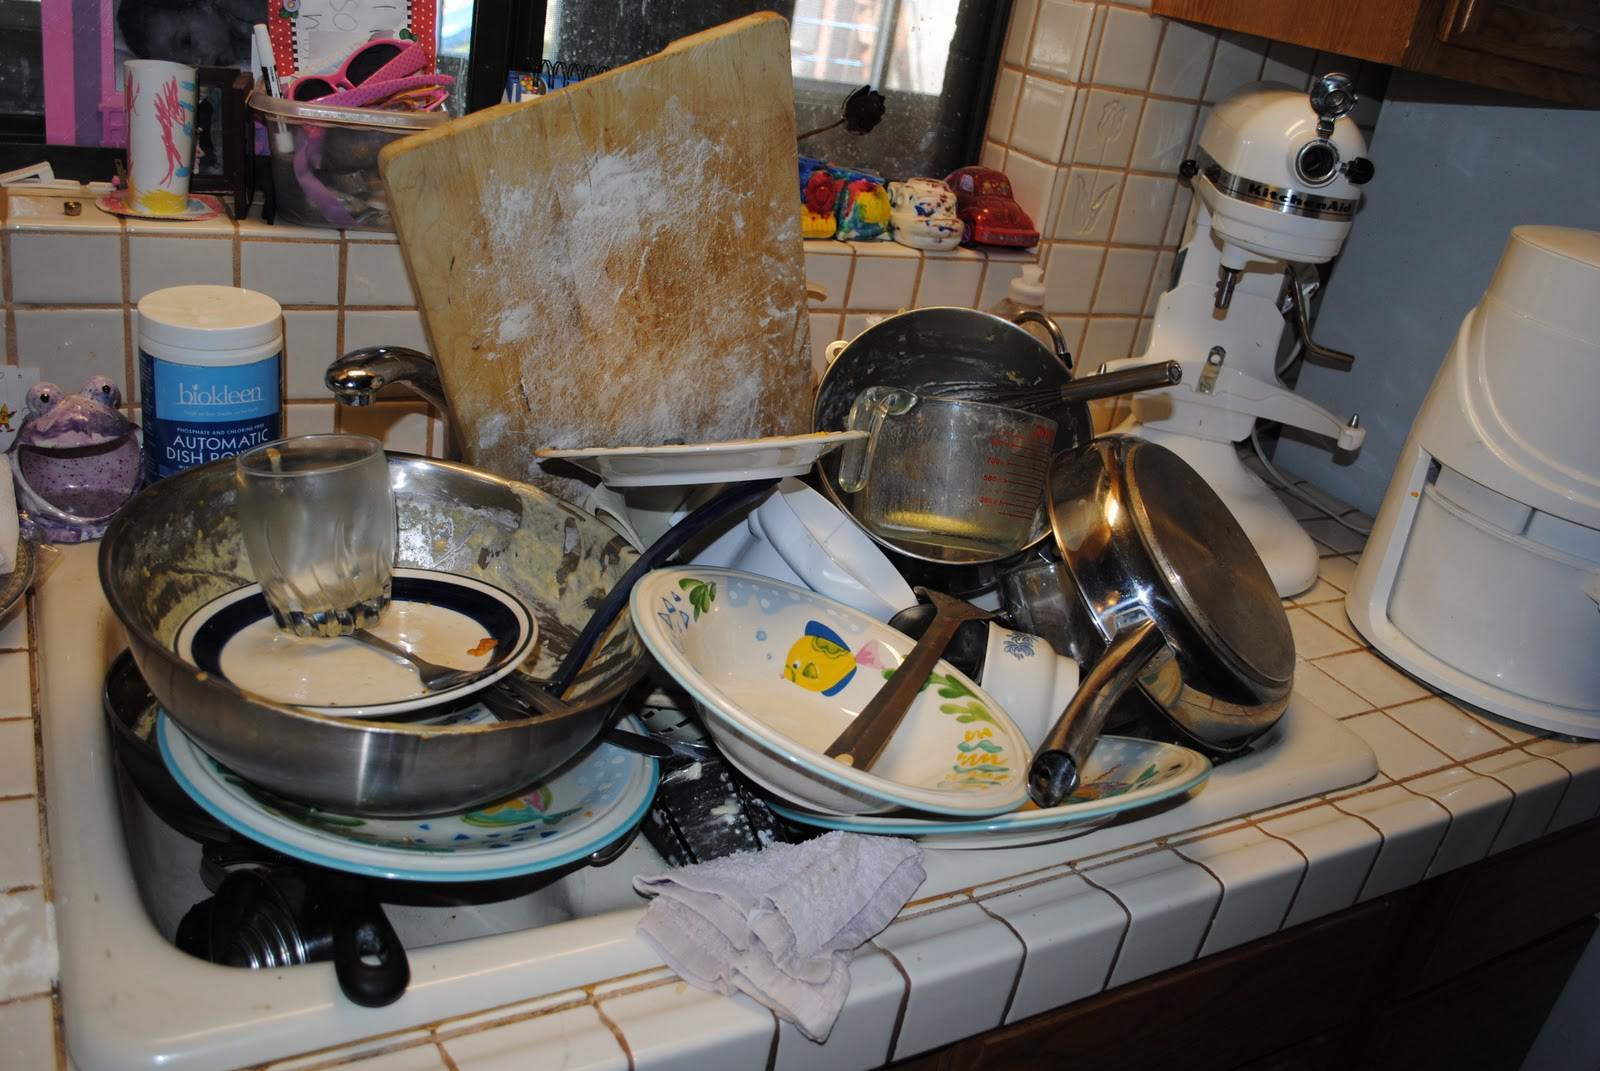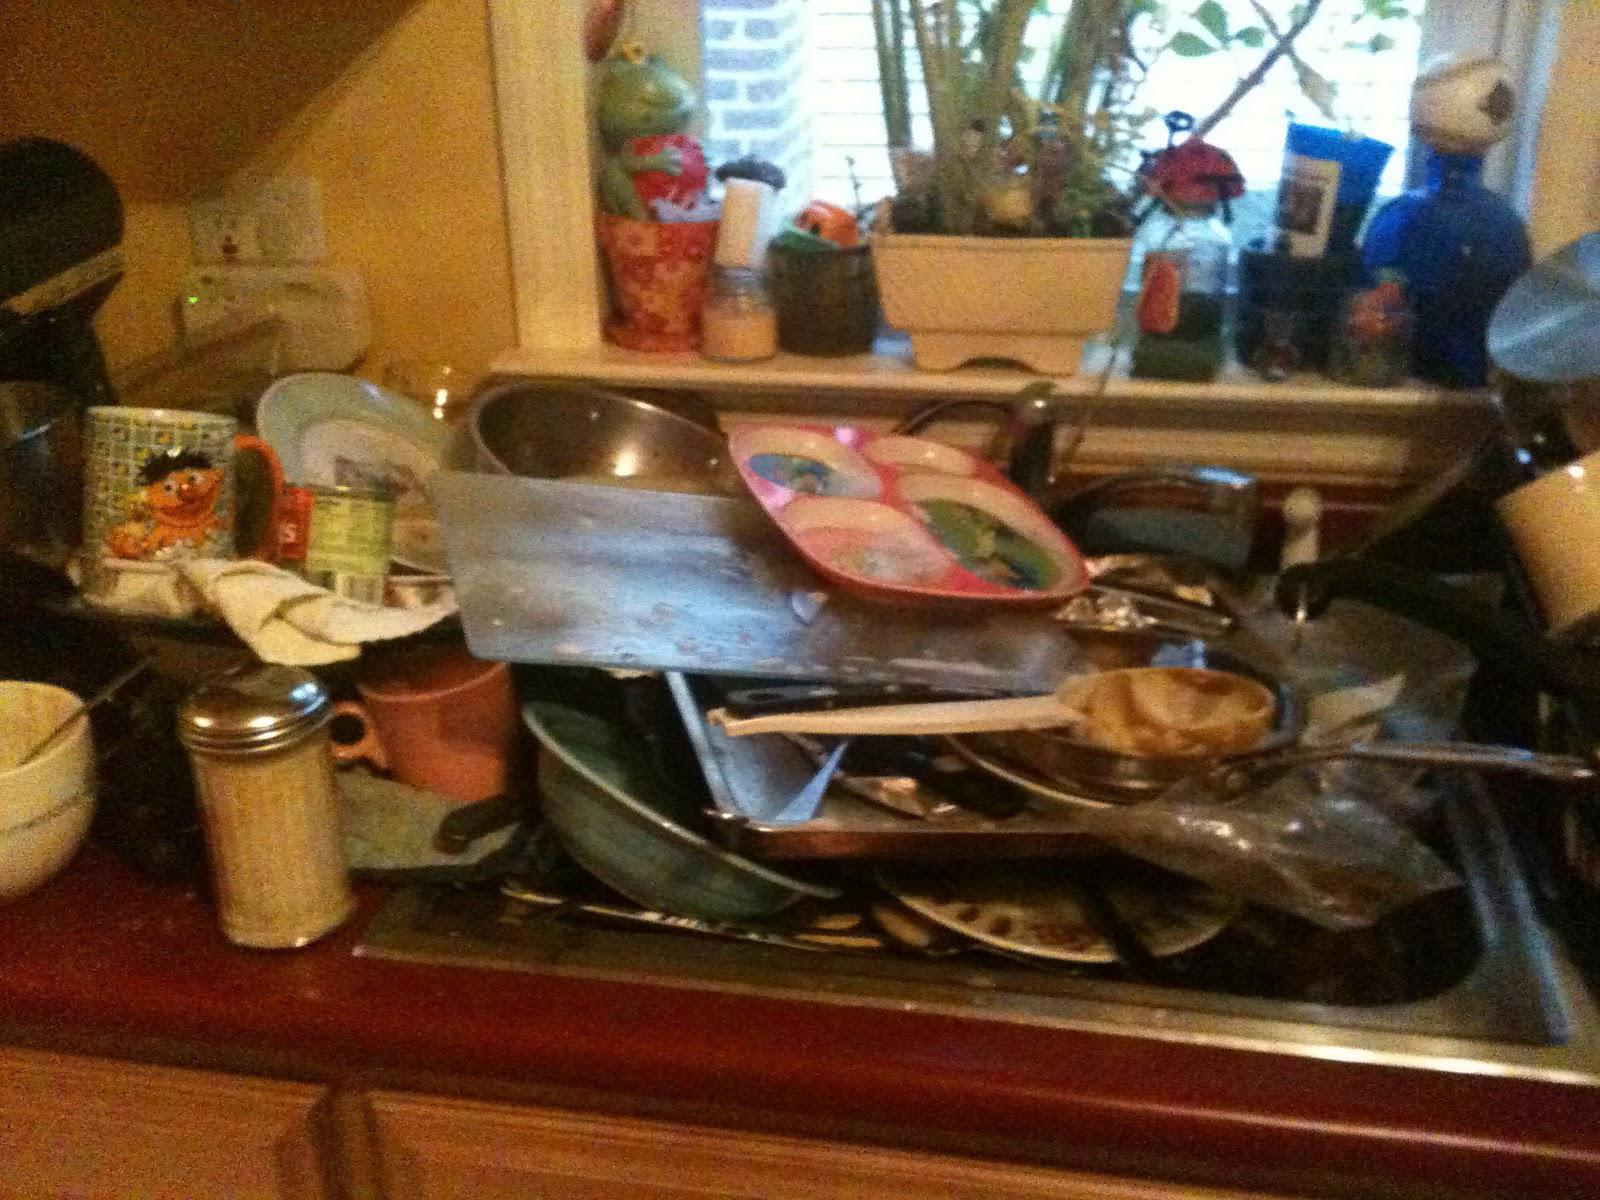The first image is the image on the left, the second image is the image on the right. Analyze the images presented: Is the assertion "A big upright squarish cutting board is behind a heaping pile of dirty dishes in a sink." valid? Answer yes or no. Yes. The first image is the image on the left, the second image is the image on the right. Assess this claim about the two images: "At least one window is visible behind a pile of dirty dishes.". Correct or not? Answer yes or no. Yes. 